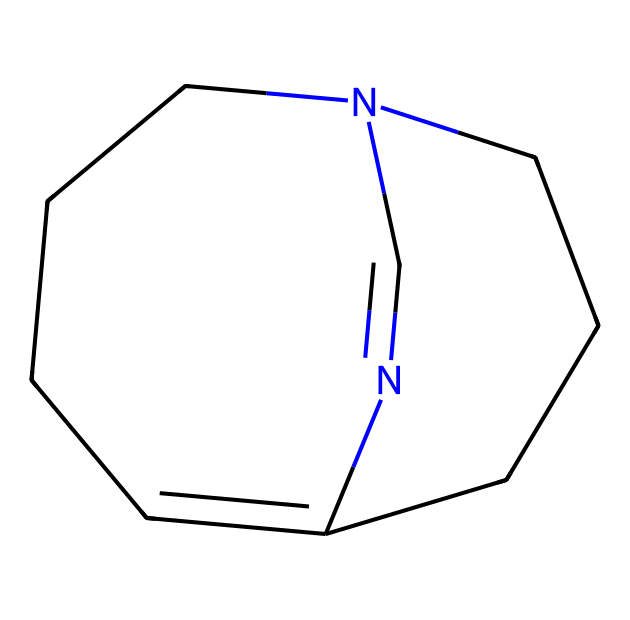What is the number of nitrogen atoms in this molecule? The SMILES representation indicates the presence of two nitrogen atoms, both of which are part of the bicyclic structure in 1,8-diazabicyclo[5.4.0]undec-7-ene.
Answer: 2 How many rings are present in the structure? Analyzing the SMILES notation reveals that the molecule has two interconnected ring systems, characteristic of a bicyclic structure.
Answer: 2 What type of hybridization do the nitrogen atoms exhibit? Based on the structural arrangement in the SMILES, both nitrogen atoms are involved in forming bonds within the rings, suggesting that they have sp3 hybridization due to their involvement in single bonds.
Answer: sp3 What is the overall molecular formula for DBU? By counting all atoms from the SMILES representation, we find a total of 12 carbon atoms, 14 hydrogen atoms, and 2 nitrogen atoms, leading to the formula C12H14N2.
Answer: C12H14N2 Which type of chemical reaction does DBU primarily facilitate? DBU is known to act as a strong base, often utilized in deprotonation reactions and facilitating nucleophilic substitutions, which are common in organic synthesis.
Answer: deprotonation What property of DBU contributes to its use in green chemistry? The ability of DBU to act as a superbase allows for efficient and sustainable reactions with lower energy requirements, making it environmentally friendly.
Answer: superbasicity How does the structure of DBU contribute to its effectiveness as a superbase? The bicyclic structure and the presence of nitrogen atoms provide a stable conjugate base upon deprotonation, enhancing its ability to accept protons and act as a strong base in reactions.
Answer: bicyclic structure and nitrogen atoms 